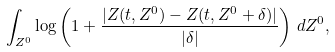Convert formula to latex. <formula><loc_0><loc_0><loc_500><loc_500>\int _ { Z ^ { 0 } } \log \left ( 1 + \frac { | Z ( t , Z ^ { 0 } ) - Z ( t , Z ^ { 0 } + \delta ) | } { | \delta | } \right ) \, d Z ^ { 0 } ,</formula> 